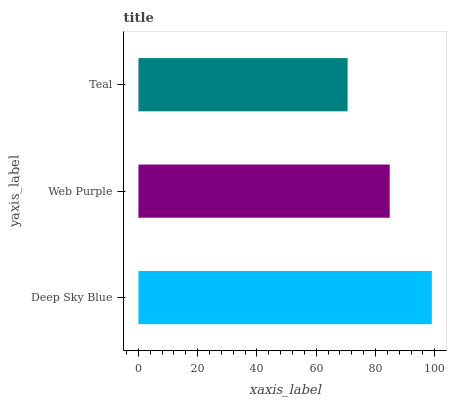Is Teal the minimum?
Answer yes or no. Yes. Is Deep Sky Blue the maximum?
Answer yes or no. Yes. Is Web Purple the minimum?
Answer yes or no. No. Is Web Purple the maximum?
Answer yes or no. No. Is Deep Sky Blue greater than Web Purple?
Answer yes or no. Yes. Is Web Purple less than Deep Sky Blue?
Answer yes or no. Yes. Is Web Purple greater than Deep Sky Blue?
Answer yes or no. No. Is Deep Sky Blue less than Web Purple?
Answer yes or no. No. Is Web Purple the high median?
Answer yes or no. Yes. Is Web Purple the low median?
Answer yes or no. Yes. Is Deep Sky Blue the high median?
Answer yes or no. No. Is Deep Sky Blue the low median?
Answer yes or no. No. 